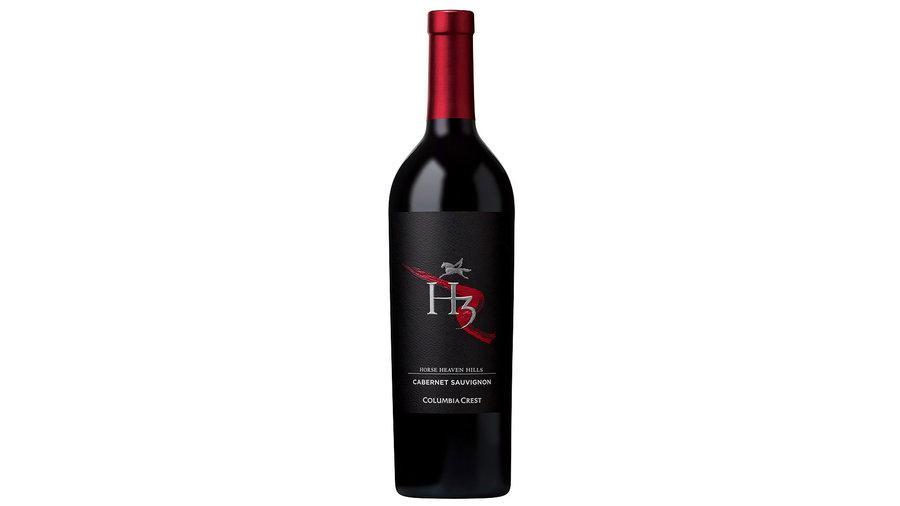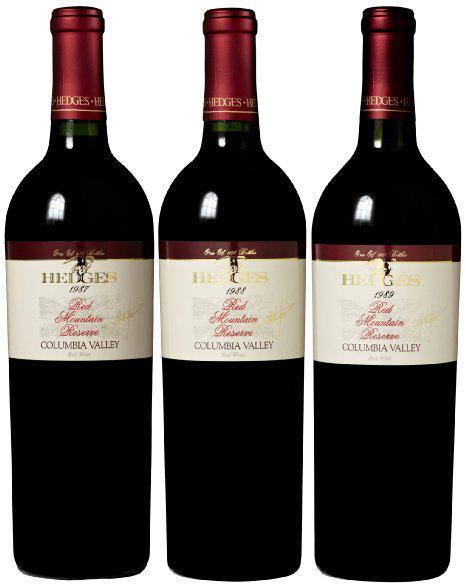The first image is the image on the left, the second image is the image on the right. Analyze the images presented: Is the assertion "One image shows exactly three bottles, all with the same shape and same bottle color." valid? Answer yes or no. Yes. The first image is the image on the left, the second image is the image on the right. Assess this claim about the two images: "The right image contains exactly three wine bottles in a horizontal row.". Correct or not? Answer yes or no. Yes. 